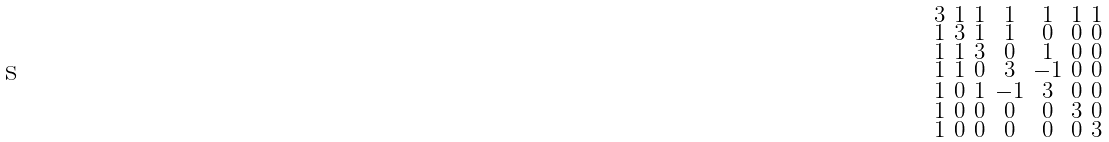<formula> <loc_0><loc_0><loc_500><loc_500>\begin{smallmatrix} 3 & 1 & 1 & 1 & 1 & 1 & 1 \\ 1 & 3 & 1 & 1 & 0 & 0 & 0 \\ 1 & 1 & 3 & 0 & 1 & 0 & 0 \\ 1 & 1 & 0 & 3 & - 1 & 0 & 0 \\ 1 & 0 & 1 & - 1 & 3 & 0 & 0 \\ 1 & 0 & 0 & 0 & 0 & 3 & 0 \\ 1 & 0 & 0 & 0 & 0 & 0 & 3 \end{smallmatrix}</formula> 